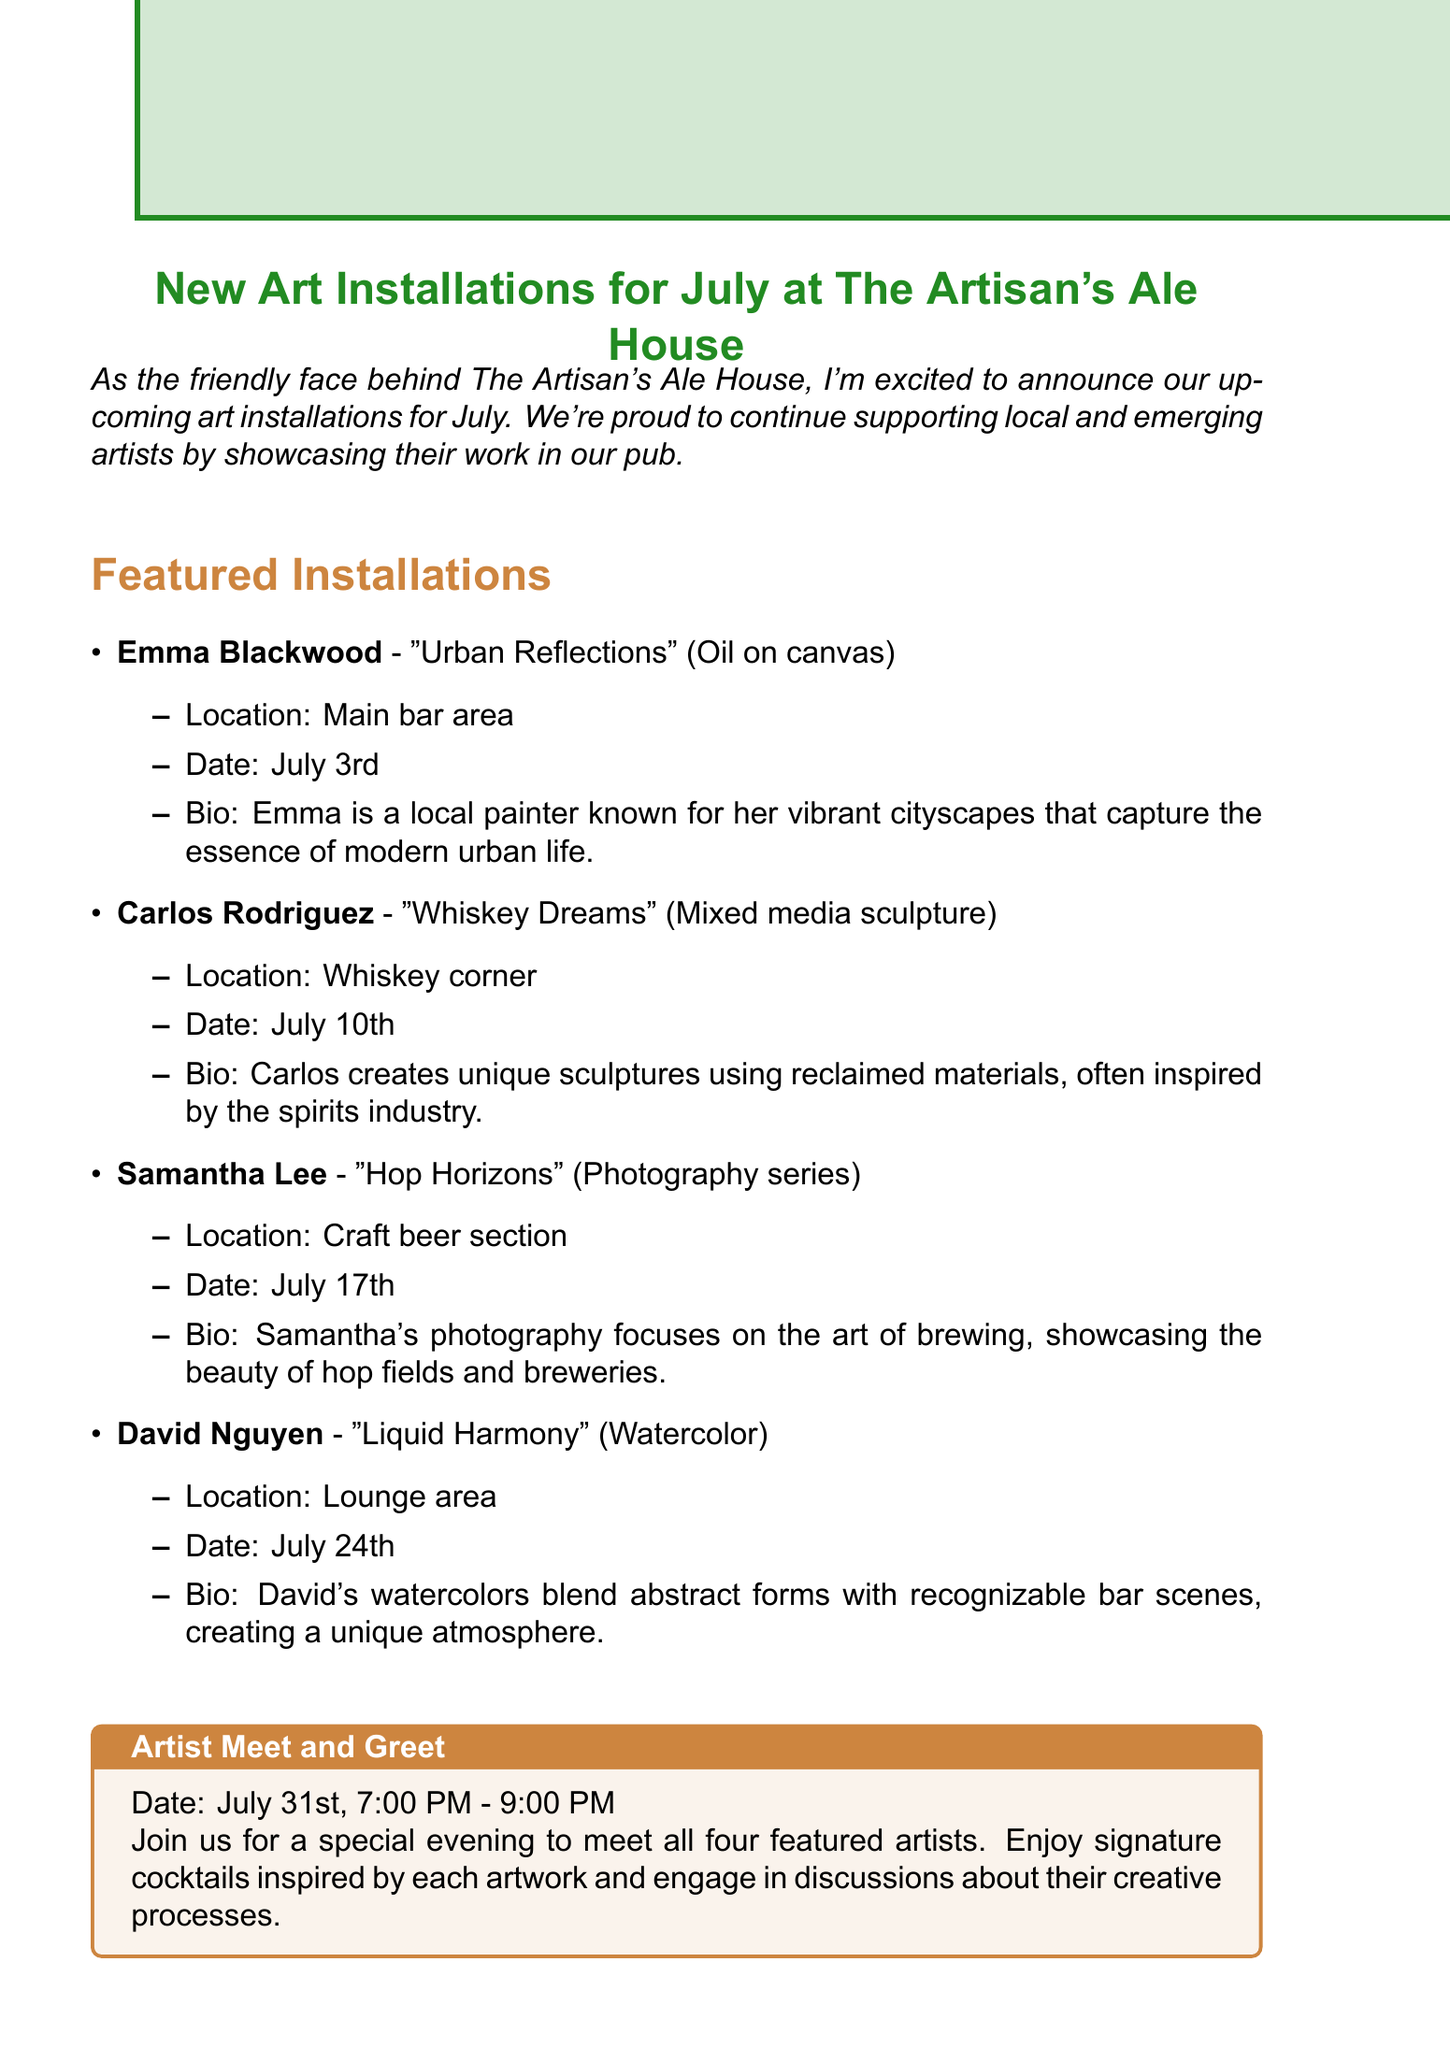What is the title of Emma Blackwood's artwork? The document states that Emma Blackwood's artwork is titled "Urban Reflections."
Answer: Urban Reflections When will the installations be held? The installation dates for the artworks are mentioned throughout the document, including July 3rd, July 10th, July 17th, and July 24th.
Answer: July 3rd, July 10th, July 17th, July 24th Where will Carlos Rodriguez's art be displayed? The document specifies that Carlos Rodriguez's artwork will be displayed in the Whiskey corner.
Answer: Whiskey corner What is the date and time of the artist meet and greet? The document details the event for July 31st from 7:00 PM to 9:00 PM.
Answer: July 31st, 7:00 PM - 9:00 PM What medium does David Nguyen use for his artwork? The document mentions that David Nguyen's medium is watercolor.
Answer: Watercolor How many artists are featured in the installations? The document lists four different artists involved in the upcoming installations at the pub.
Answer: Four Which section of the pub will Samantha Lee's photography series be located in? The document indicates that her photography series "Hop Horizons" will be in the craft beer section.
Answer: Craft beer section What special offer is available for guests who purchase artwork? The document explains that guests who purchase any artwork will receive a complimentary flight of craft beers.
Answer: Complimentary flight of craft beers 